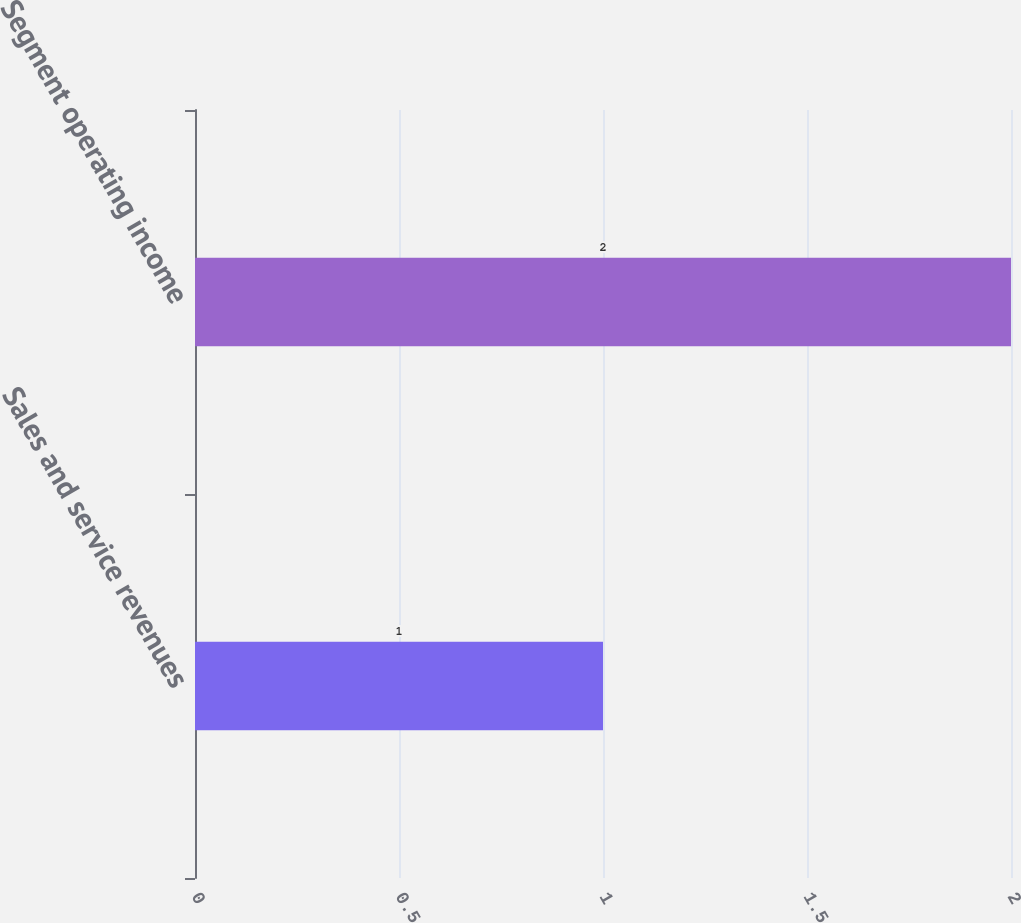Convert chart. <chart><loc_0><loc_0><loc_500><loc_500><bar_chart><fcel>Sales and service revenues<fcel>Segment operating income<nl><fcel>1<fcel>2<nl></chart> 